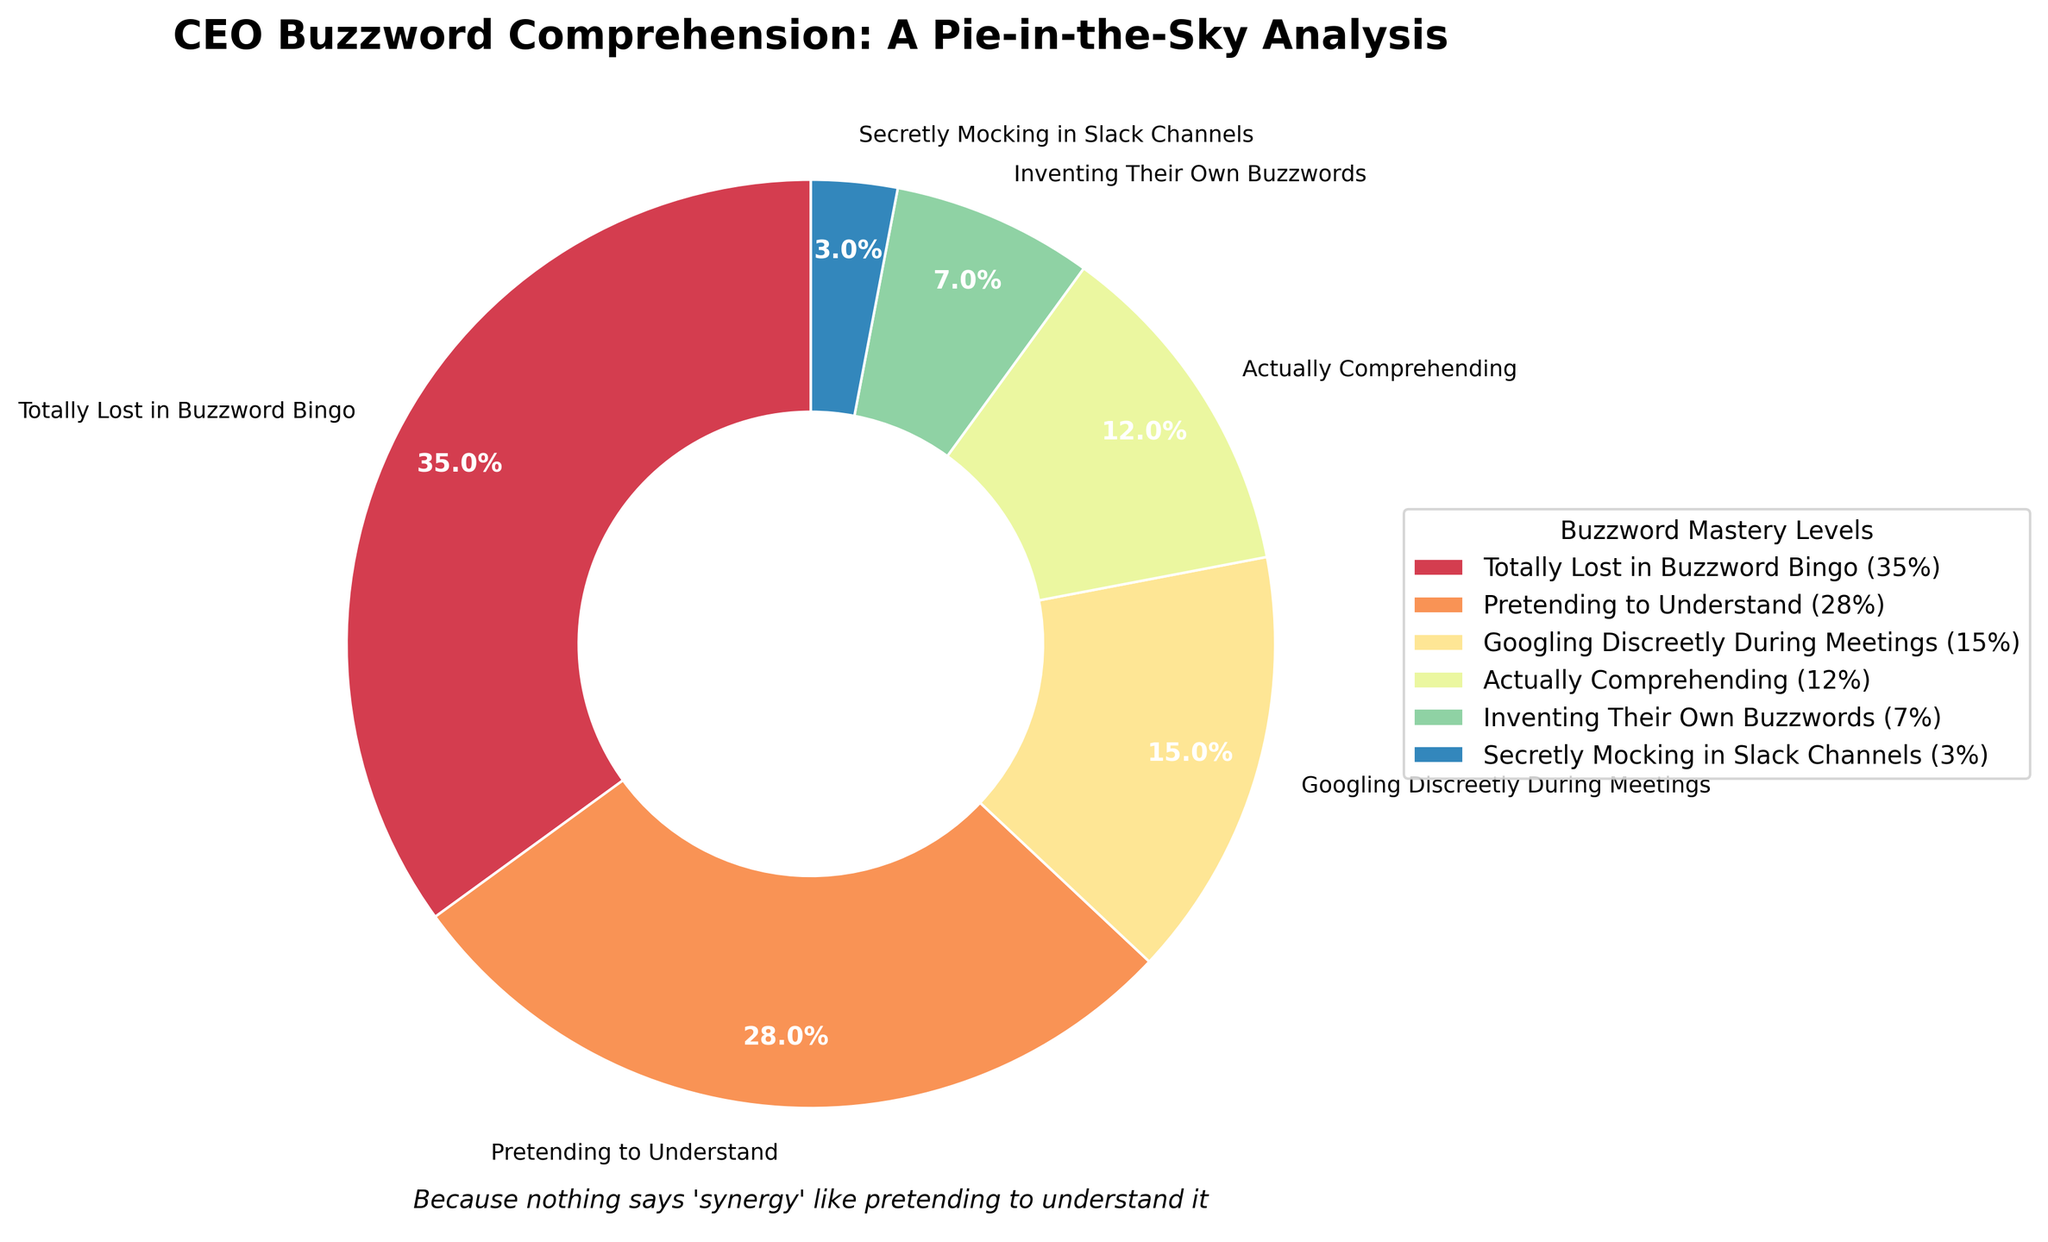What's the sum of the percentages for "Totally Lost in Buzzword Bingo" and "Pretending to Understand"? To find the sum, we add the percentages of "Totally Lost in Buzzword Bingo" (35%) and "Pretending to Understand" (28%). Thus, 35 + 28 = 63%
Answer: 63% Which category has the smallest percentage, and what is it? To determine the smallest percentage, we compare each category's percentages: "Secretly Mocking in Slack Channels" is the smallest with 3%.
Answer: "Secretly Mocking in Slack Channels", 3% What is the difference in percentage between "Googling Discreetly During Meetings" and "Actually Comprehending"? We find the difference by subtracting "Actually Comprehending" (12%) from "Googling Discreetly During Meetings" (15%). Thus, 15 - 12 = 3%.
Answer: 3% Which category has a higher percentage: "Inventing Their Own Buzzwords" or "Actually Comprehending", and by how much? "Actually Comprehending" has 12%, and "Inventing Their Own Buzzwords" has 7%. So, 12 - 7 = 5%; "Actually Comprehending" is higher by 5%.
Answer: "Actually Comprehending" by 5% What is the combined percentage of all the categories where people do not understand the CEO's buzzwords? Add the percentages for "Totally Lost in Buzzword Bingo" (35%), "Pretending to Understand" (28%), and "Googling Discreetly During Meetings" (15%) to get 35 + 28 + 15 = 78%.
Answer: 78% What's the average percentage of all listed categories? To calculate the average, sum the percentages and divide by the number of categories: (35 + 28 + 15 + 12 + 7 + 3) / 6 = 100 / 6 ≈ 16.67%.
Answer: 16.67% Which category's section in the pie chart is next to the section for "Pretending to Understand"? According to the category order starting from the top, "Googling Discreetly During Meetings" and "Totally Lost in Buzzword Bingo" are next to "Pretending to Understand".
Answer: "Googling Discreetly During Meetings" and "Totally Lost in Buzzword Bingo" What percentage of professionals are either "Pretending to Understand" or "Googling Discreetly During Meetings"? Sum the percentages for "Pretending to Understand" (28%) and "Googling Discreetly During Meetings" (15%): 28 + 15 = 43%.
Answer: 43% What color is used to represent "Secretly Mocking in Slack Channels"? Based on the pie chart visualization, visually locate the color used for "Secretly Mocking in Slack Channels". It is usually presented with a specific color distinct from other sections.
Answer: Purple (assuming standard color assignments) 